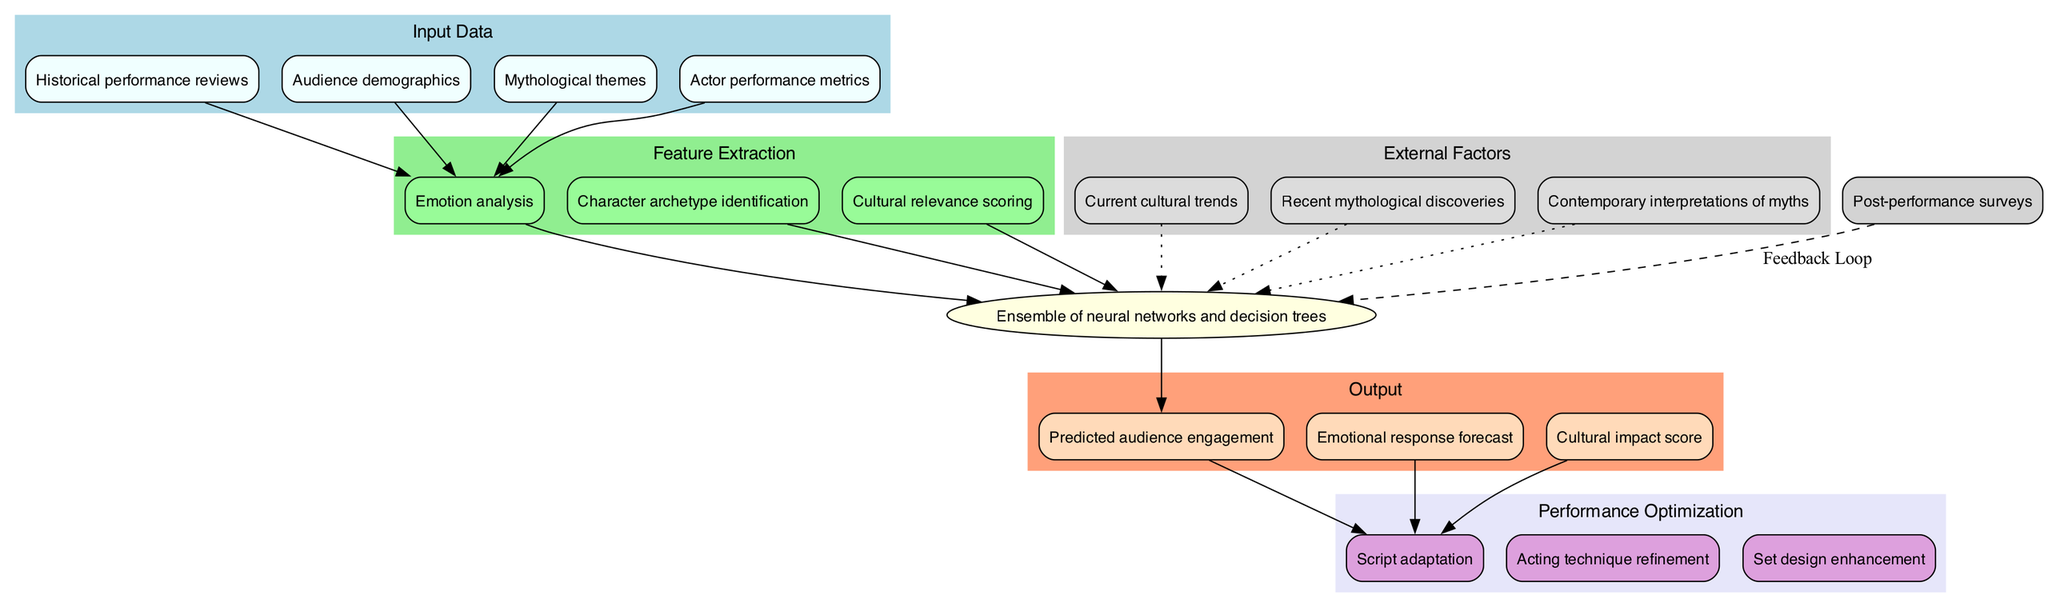What are the input data types for this model? The diagram lists four types of input data: "Historical performance reviews," "Audience demographics," "Mythological themes," and "Actor performance metrics." Each of these nodes is located in the 'Input Data' section of the diagram.
Answer: Historical performance reviews, Audience demographics, Mythological themes, Actor performance metrics How many feature extraction methods are used? The diagram shows three distinct nodes in the 'Feature Extraction' section: "Emotion analysis," "Character archetype identification," and "Cultural relevance scoring." Thus, we count these nodes to find there are three methods.
Answer: 3 What is the model type used in this diagram? The model node specifically indicates that an "Ensemble of neural networks and decision trees" is being utilized. This is a direct reading from the model node in the center of the diagram.
Answer: Ensemble of neural networks and decision trees Which output is associated with the model? The output node list shows three items directly connected to the model, one of which is the first output "Predicted audience engagement." This is visually linked to the model node in the output section of the diagram.
Answer: Predicted audience engagement What feedback mechanism is included in this model? A dashed edge connects "Post-performance surveys" to the model, emphasizing that this represents the feedback loop utilized to update and optimize the model.
Answer: Post-performance surveys How do external factors influence the model? The diagram features three external factors identified through dotted edges connecting them to the model. This means these factors are considered in the model’s predictions and adjustments.
Answer: Current cultural trends, Recent mythological discoveries, Contemporary interpretations of myths What type of optimization methods are linked to the model output? There are three optimization methods listed in the 'Performance Optimization' section: "Script adaptation," "Acting technique refinement," and "Set design enhancement." They are linked to the output nodes in the diagram.
Answer: Script adaptation, Acting technique refinement, Set design enhancement What is the relationship between the input data and feature extraction? The diagram illustrates edges from each input data type leading to the first feature extraction method, meaning all input data contribute to the extraction of features for the model.
Answer: Input data contributes to feature extraction Which configuration allows for the measuring of cultural impact? The output list contains "Cultural impact score" as one of the outputs, indicating that this score is part of how the model measures and predicts cultural impact after processing the inputs and model predictions.
Answer: Cultural impact score 